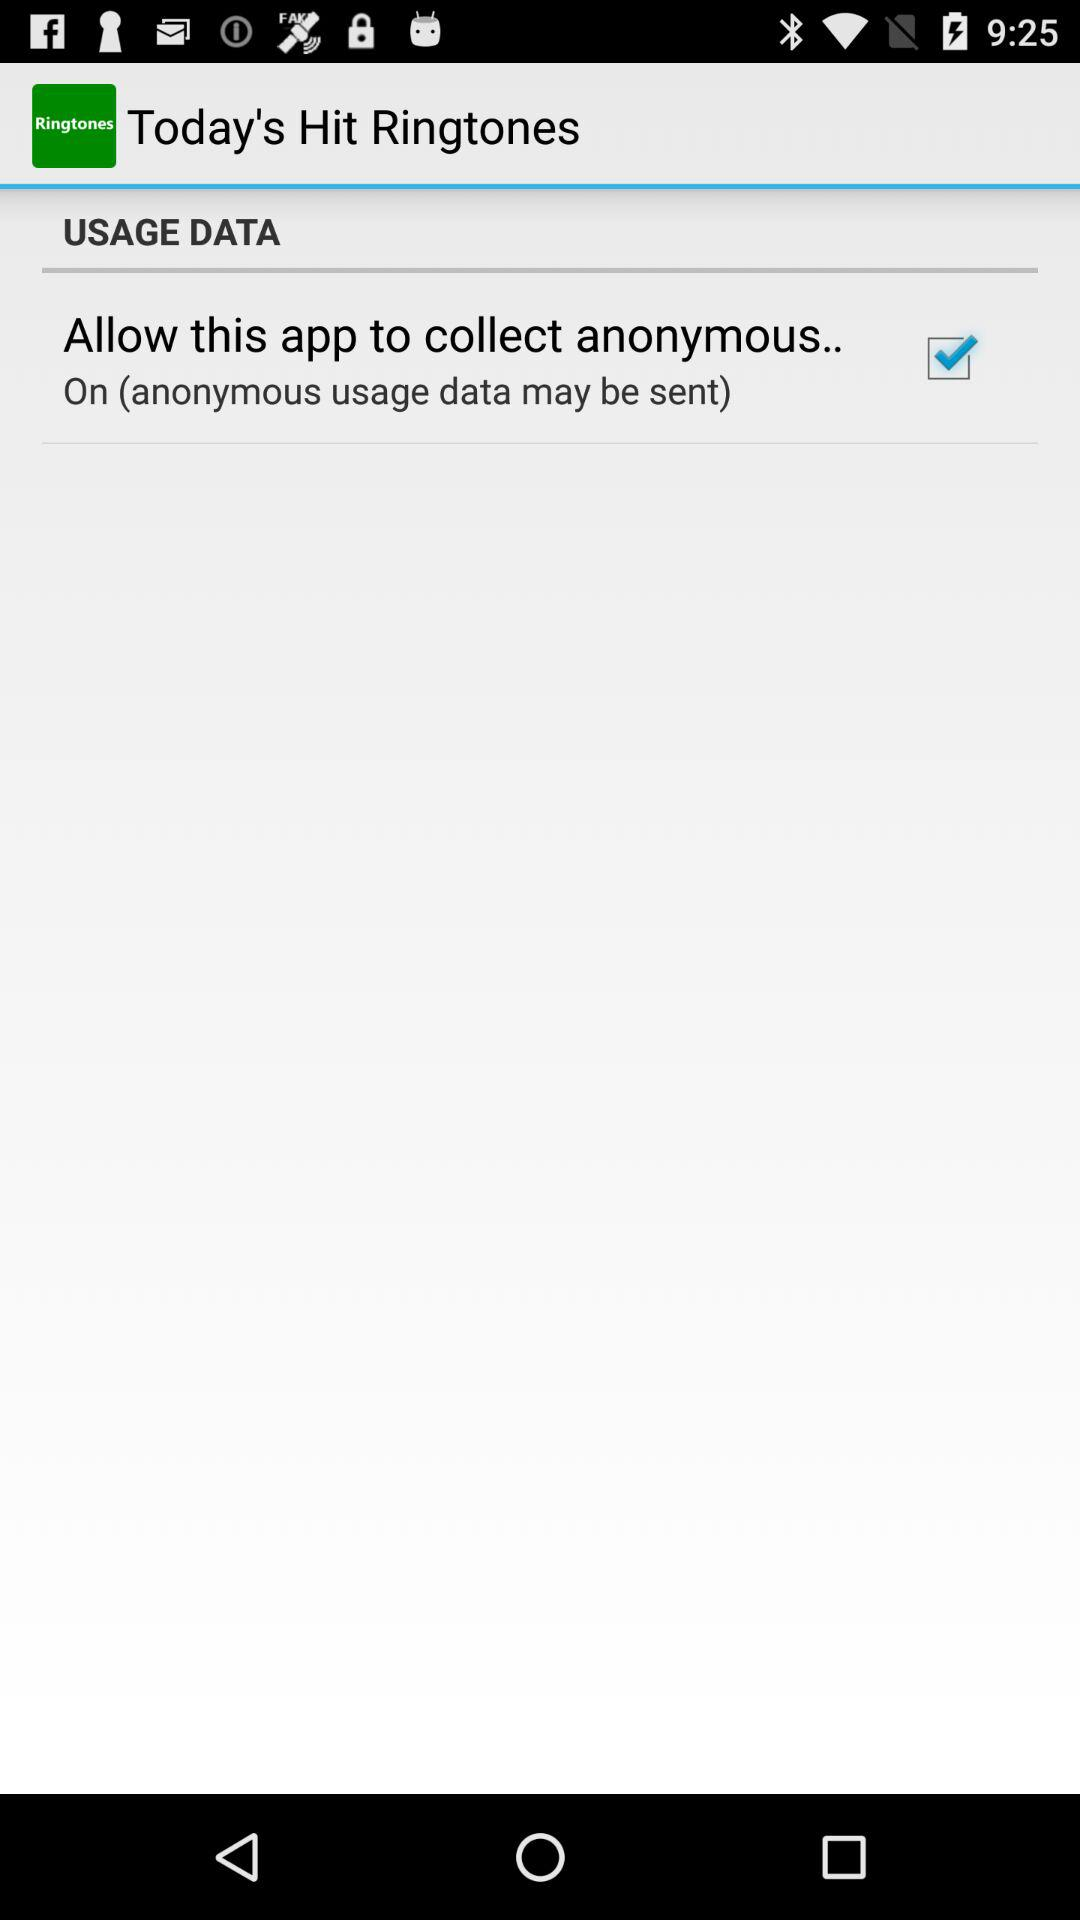What is the status of "Allow this app to collect anonymous.."? The status of "Allow this app to collect anonymous.." is "on". 